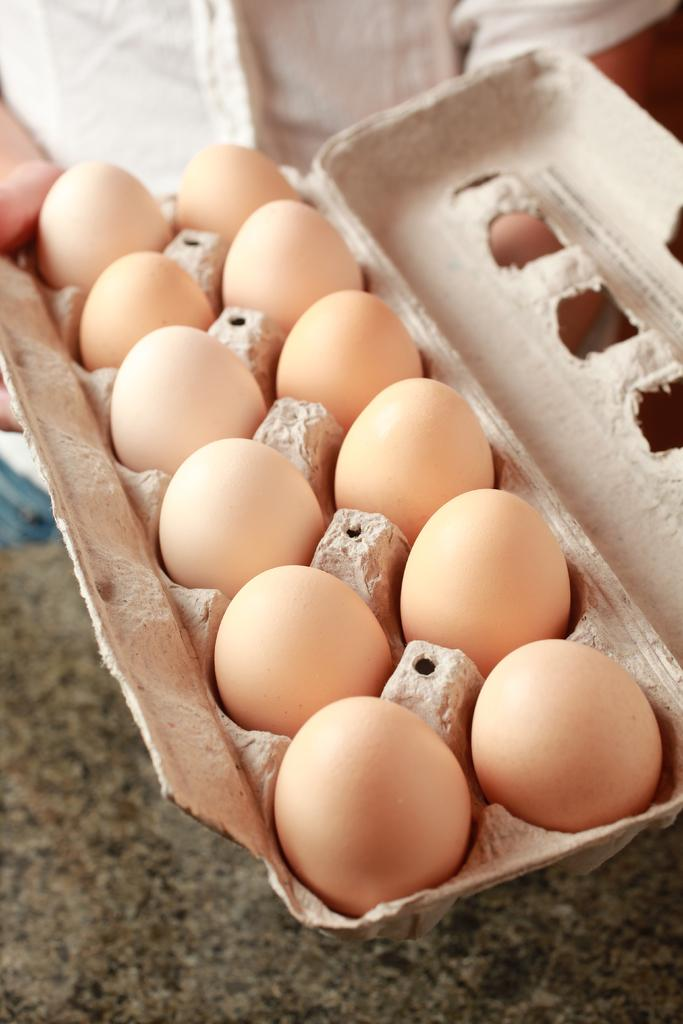What objects are present in the image? There are eggs in the image. How are the eggs arranged in the image? The eggs are placed in an egg tray. What is the color of the eggs in the image? The eggs are in cream color. How many times does the laborer sneeze while holding the bottle in the image? There is no laborer or bottle present in the image; it only features eggs in an egg tray. 